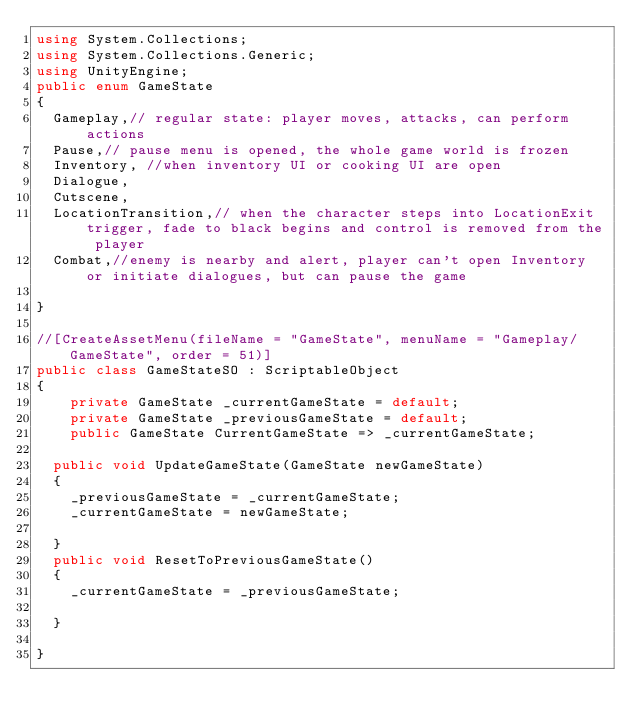<code> <loc_0><loc_0><loc_500><loc_500><_C#_>using System.Collections;
using System.Collections.Generic;
using UnityEngine;
public enum GameState
{
	Gameplay,// regular state: player moves, attacks, can perform actions
	Pause,// pause menu is opened, the whole game world is frozen
	Inventory, //when inventory UI or cooking UI are open
	Dialogue,
	Cutscene,
	LocationTransition,// when the character steps into LocationExit trigger, fade to black begins and control is removed from the player
	Combat,//enemy is nearby and alert, player can't open Inventory or initiate dialogues, but can pause the game

}

//[CreateAssetMenu(fileName = "GameState", menuName = "Gameplay/GameState", order = 51)]
public class GameStateSO : ScriptableObject
{
    private GameState _currentGameState = default;
    private GameState _previousGameState = default; 
    public GameState CurrentGameState => _currentGameState;

	public void UpdateGameState(GameState newGameState)
	{
		_previousGameState = _currentGameState;
		_currentGameState = newGameState;

	}
	public void ResetToPreviousGameState()
	{
		_currentGameState = _previousGameState;

	}

}
</code> 